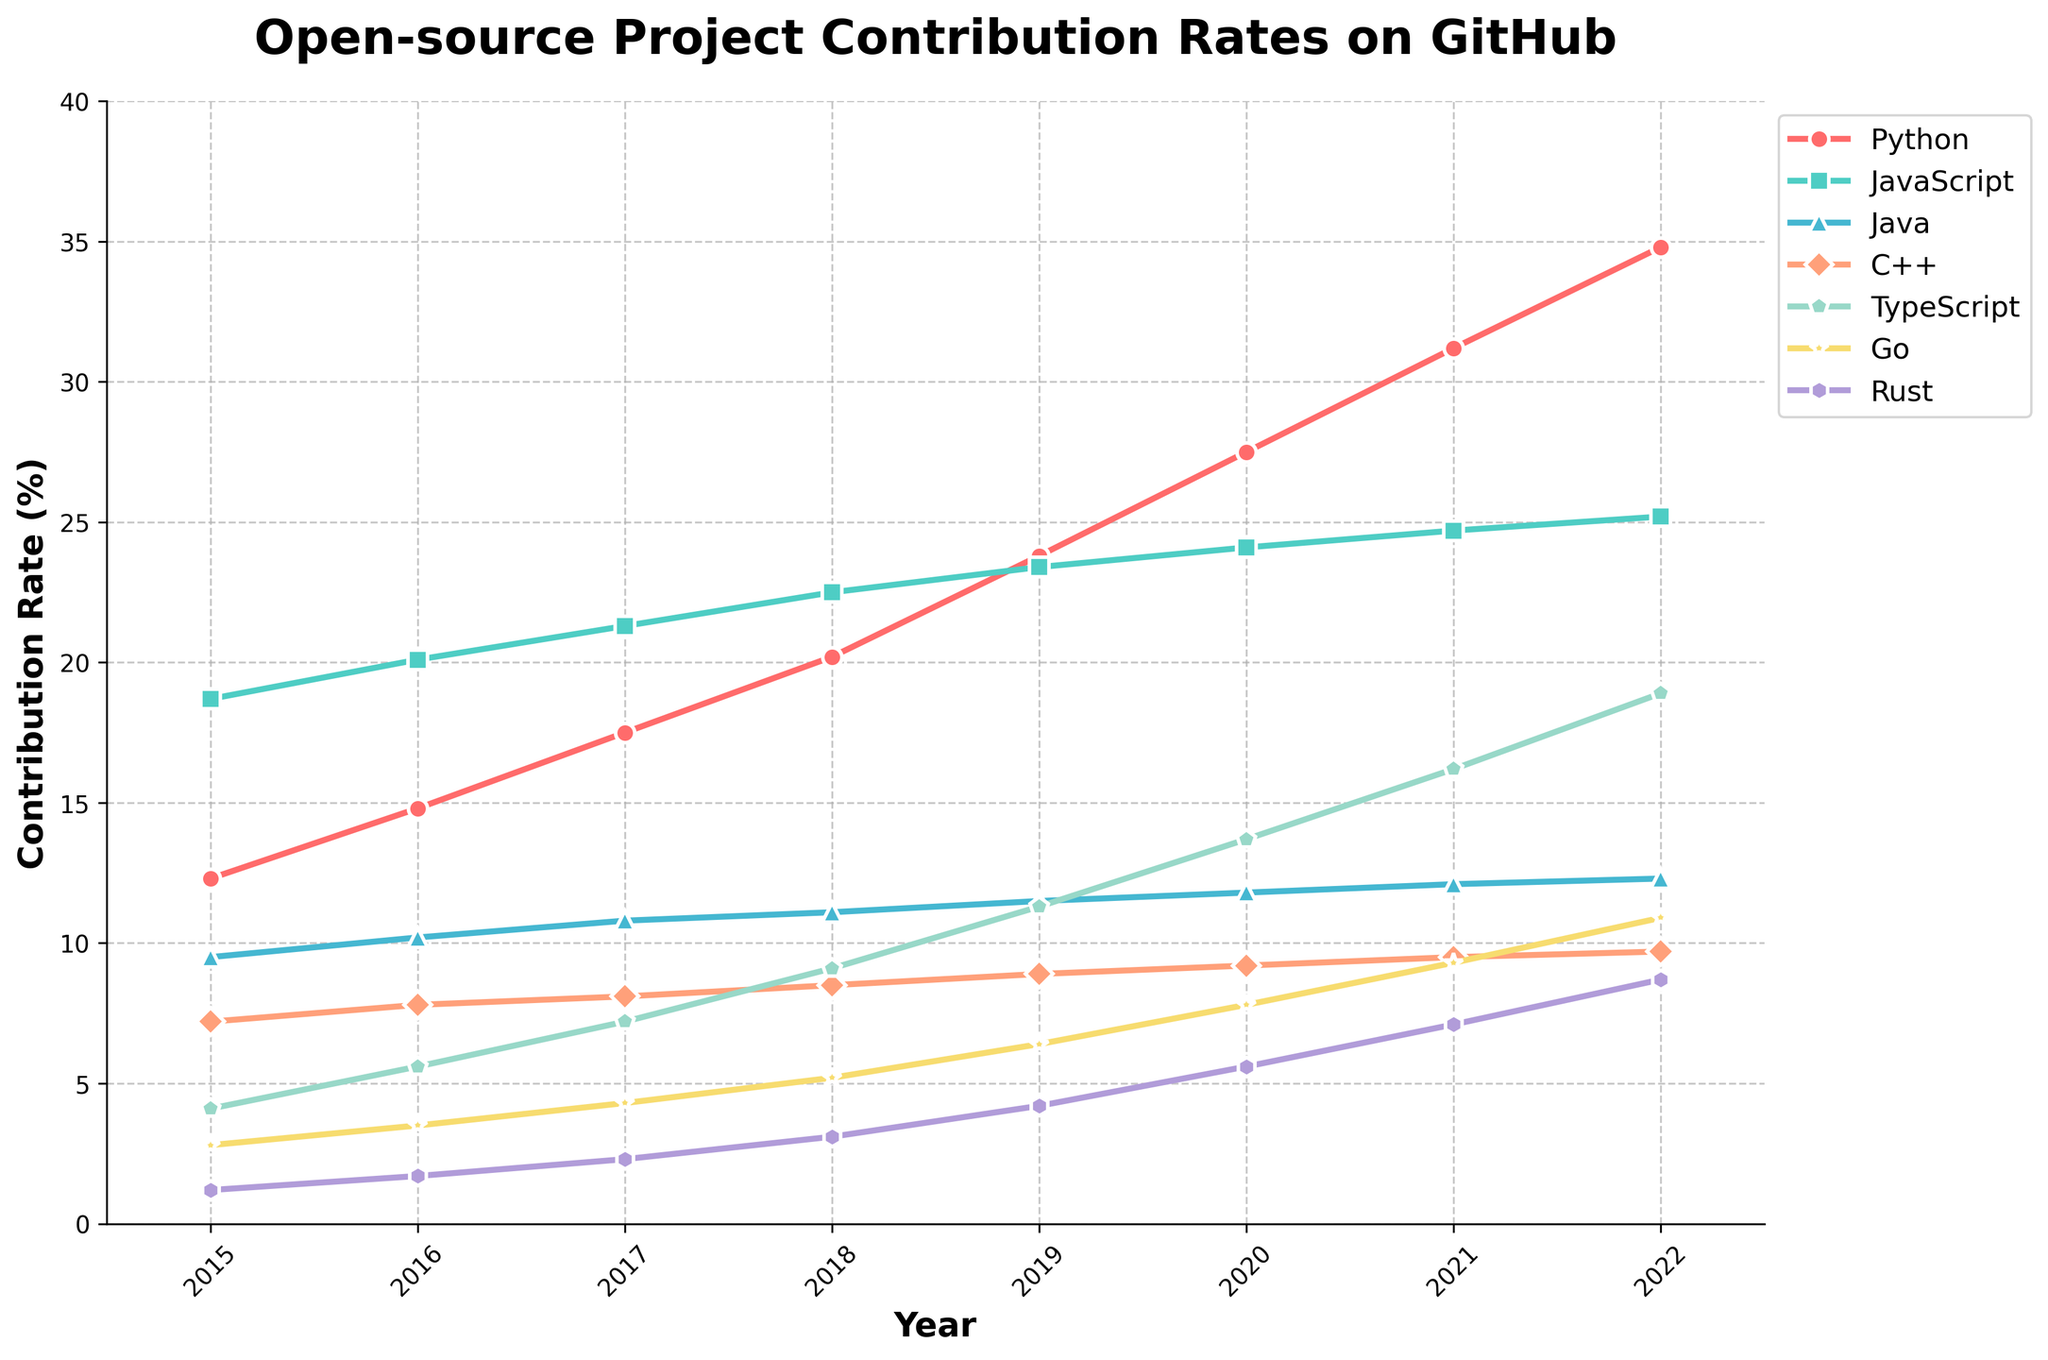What is the general trend for Python's contribution rate from 2015 to 2022? The trend for Python's contribution rate can be observed by following the line representing Python from the left (2015) to the right (2022). The line starts at 12.3% in 2015 and steadily increases each year, reaching 34.8% in 2022.
Answer: Increasing Which language surpassed TypeScript in contribution rate first, Go or Rust? To determine which language surpassed TypeScript in contribution rate first, compare the change in contribution rates over the years. Rust's contribution rate crosses that of TypeScript in 2020 when Rust is at 5.6% and TypeScript is at 4.1%, while Go only surpasses TypeScript from 2021 onwards.
Answer: Rust What is the difference in contribution rates between JavaScript and Python in 2020? By checking the specific data points for 2020, JavaScript has a contribution rate of 24.1 whereas Python is at 27.5. The difference is calculated as 27.5 - 24.1 = 3.4.
Answer: 3.4 How does the contribution rate of C++ in 2022 compare to its rate in 2015? In 2015, the contribution rate for C++ is 7.2%, while in 2022, it is 9.7%. Comparing these values, C++ has increased by 9.7 - 7.2 = 2.5 percentage points.
Answer: Increased by 2.5 Which language had the highest contribution rate in 2018? By examining the contribution rates for each language in 2018, JavaScript has the highest contribution rate with 22.5%.
Answer: JavaScript What is the total contribution rate for JavaScript over the entire period from 2015 to 2022? To determine the total, sum the JavaScript contribution rate for each year: 18.7 + 20.1 + 21.3 + 22.5 + 23.4 + 24.1 + 24.7 + 25.2. This totals to 180.
Answer: 180 Which languages show a clear upward trend over all the years shown? Looking at the lines in the graph, Python, TypeScript, and Rust show a clear upward trend from 2015 to 2022, with no years of decrease or stagnation.
Answer: Python, TypeScript, Rust Comparing Java and Go, which had a higher contribution rate in 2019, and by how much? For 2019, Java has a rate of 11.5% and Go has a rate of 6.4%. The difference is calculated as 11.5 - 6.4 = 5.1.
Answer: Java by 5.1 Between 2016 and 2017, which language saw the largest increase in contribution rate? By examining the differences between 2016 and 2017 for each language, Python increased by 2.7, JavaScript by 1.2, Java by 0.6, C++ by 0.3, TypeScript by 1.6, Go by 0.8, and Rust by 0.6. Python's increase of 2.7 is the largest.
Answer: Python 